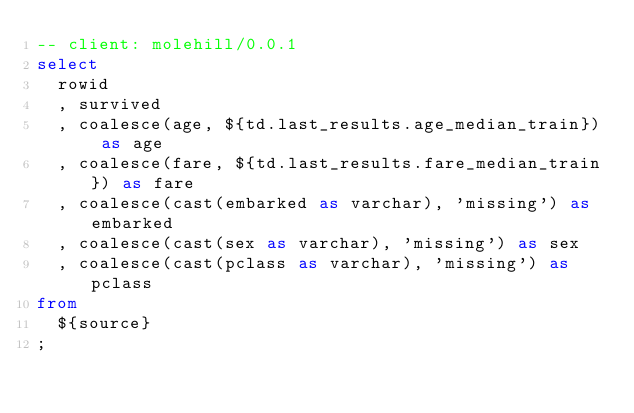<code> <loc_0><loc_0><loc_500><loc_500><_SQL_>-- client: molehill/0.0.1
select
  rowid
  , survived
  , coalesce(age, ${td.last_results.age_median_train}) as age
  , coalesce(fare, ${td.last_results.fare_median_train}) as fare
  , coalesce(cast(embarked as varchar), 'missing') as embarked
  , coalesce(cast(sex as varchar), 'missing') as sex
  , coalesce(cast(pclass as varchar), 'missing') as pclass
from
  ${source}
;
</code> 